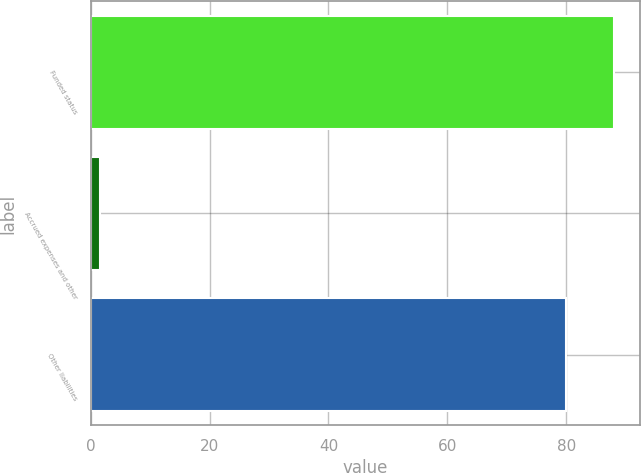Convert chart to OTSL. <chart><loc_0><loc_0><loc_500><loc_500><bar_chart><fcel>Funded status<fcel>Accrued expenses and other<fcel>Other liabilities<nl><fcel>88<fcel>1.6<fcel>80<nl></chart> 